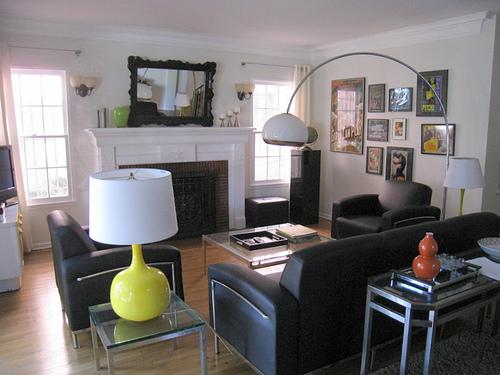What color is the mantle?
Short answer required. White. How many yellow lamps?
Quick response, please. 1. What colors are the tops of the stools?
Concise answer only. Black. How many people are in the room?
Be succinct. 0. 